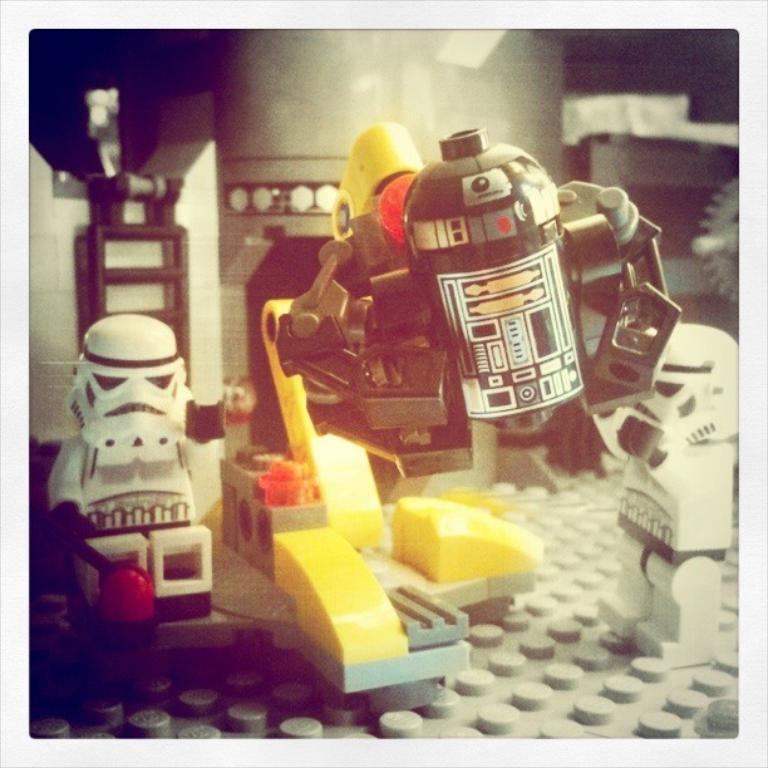What is the main subject of the image? The image contains a miniature. What type of objects are present in the miniature? There are toys in the miniature. Can you describe the appearance of the toys? The toys are in different colors and resemble minions. What type of cloth is draped over the face of the quiver in the image? There is no quiver or cloth present in the image; it features a miniature with toys resembling minions. 